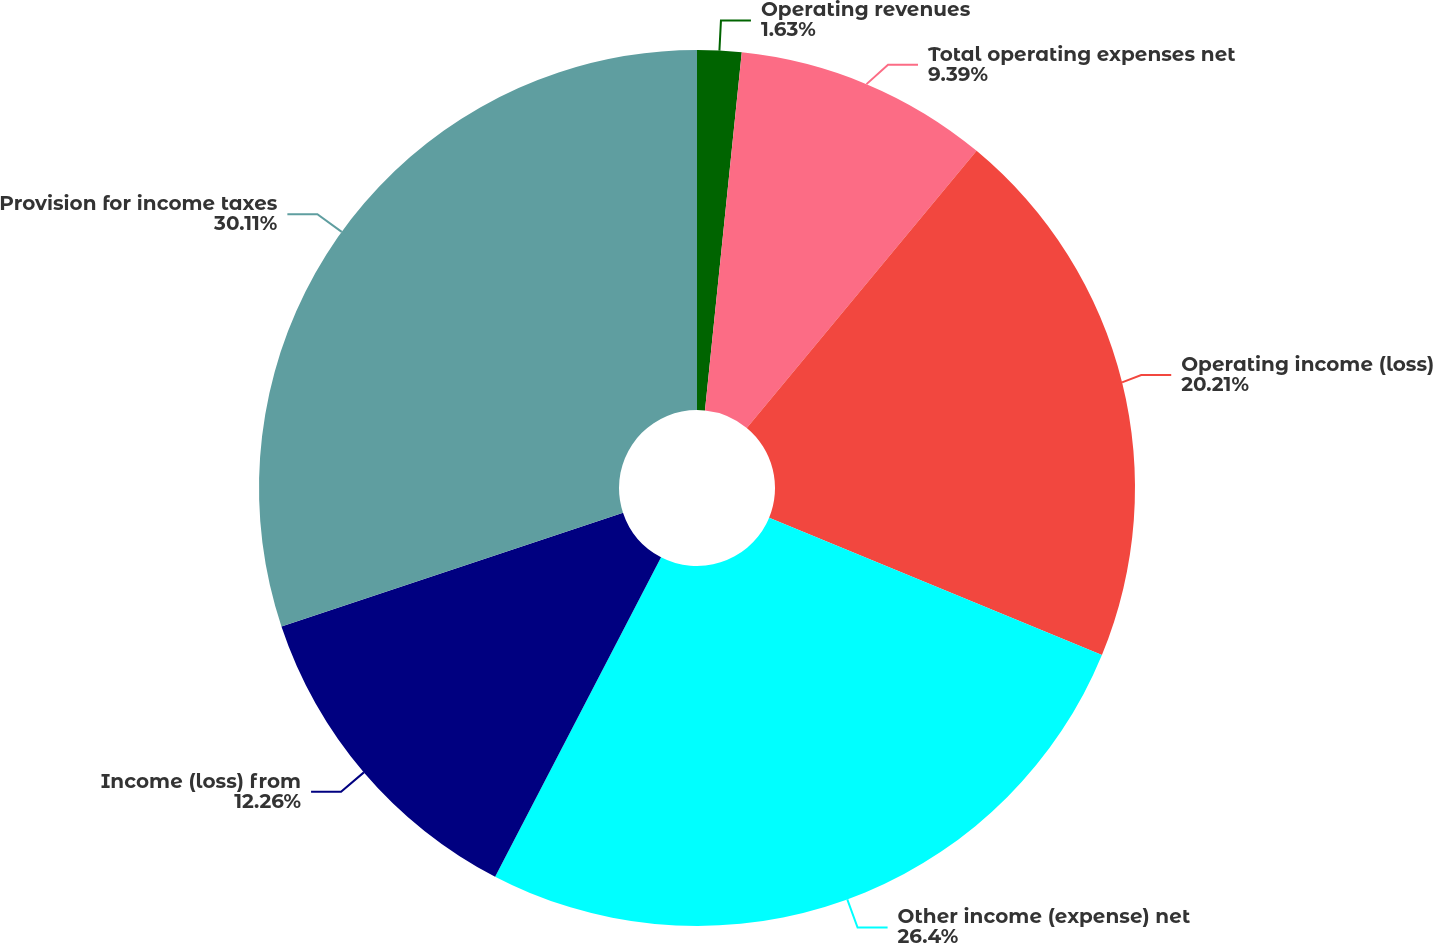Convert chart to OTSL. <chart><loc_0><loc_0><loc_500><loc_500><pie_chart><fcel>Operating revenues<fcel>Total operating expenses net<fcel>Operating income (loss)<fcel>Other income (expense) net<fcel>Income (loss) from<fcel>Provision for income taxes<nl><fcel>1.63%<fcel>9.39%<fcel>20.21%<fcel>26.4%<fcel>12.26%<fcel>30.12%<nl></chart> 